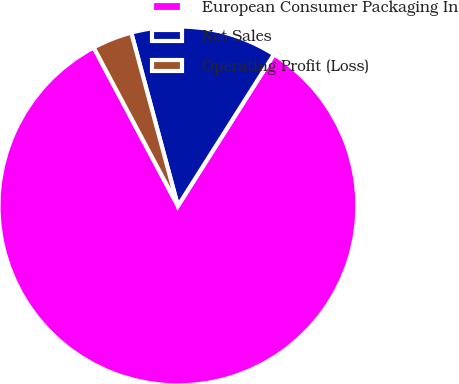<chart> <loc_0><loc_0><loc_500><loc_500><pie_chart><fcel>European Consumer Packaging In<fcel>Net Sales<fcel>Operating Profit (Loss)<nl><fcel>83.23%<fcel>13.18%<fcel>3.59%<nl></chart> 